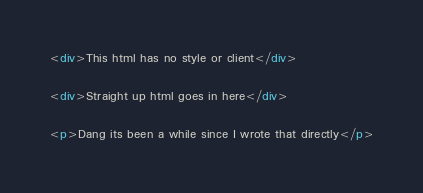<code> <loc_0><loc_0><loc_500><loc_500><_HTML_><div>This html has no style or client</div>

<div>Straight up html goes in here</div>

<p>Dang its been a while since I wrote that directly</p>
</code> 